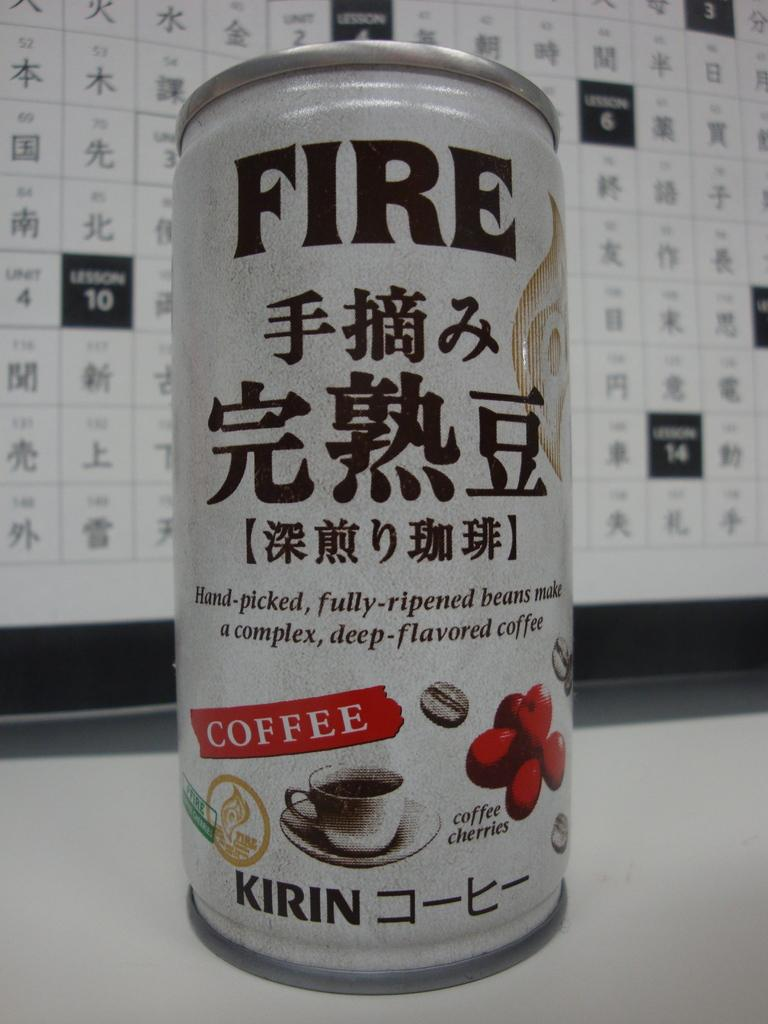<image>
Share a concise interpretation of the image provided. White can which says the word COFFEE on it. 